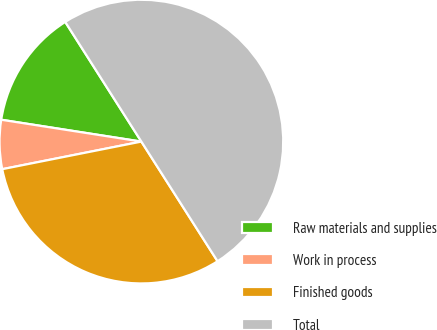Convert chart to OTSL. <chart><loc_0><loc_0><loc_500><loc_500><pie_chart><fcel>Raw materials and supplies<fcel>Work in process<fcel>Finished goods<fcel>Total<nl><fcel>13.52%<fcel>5.58%<fcel>30.91%<fcel>50.0%<nl></chart> 